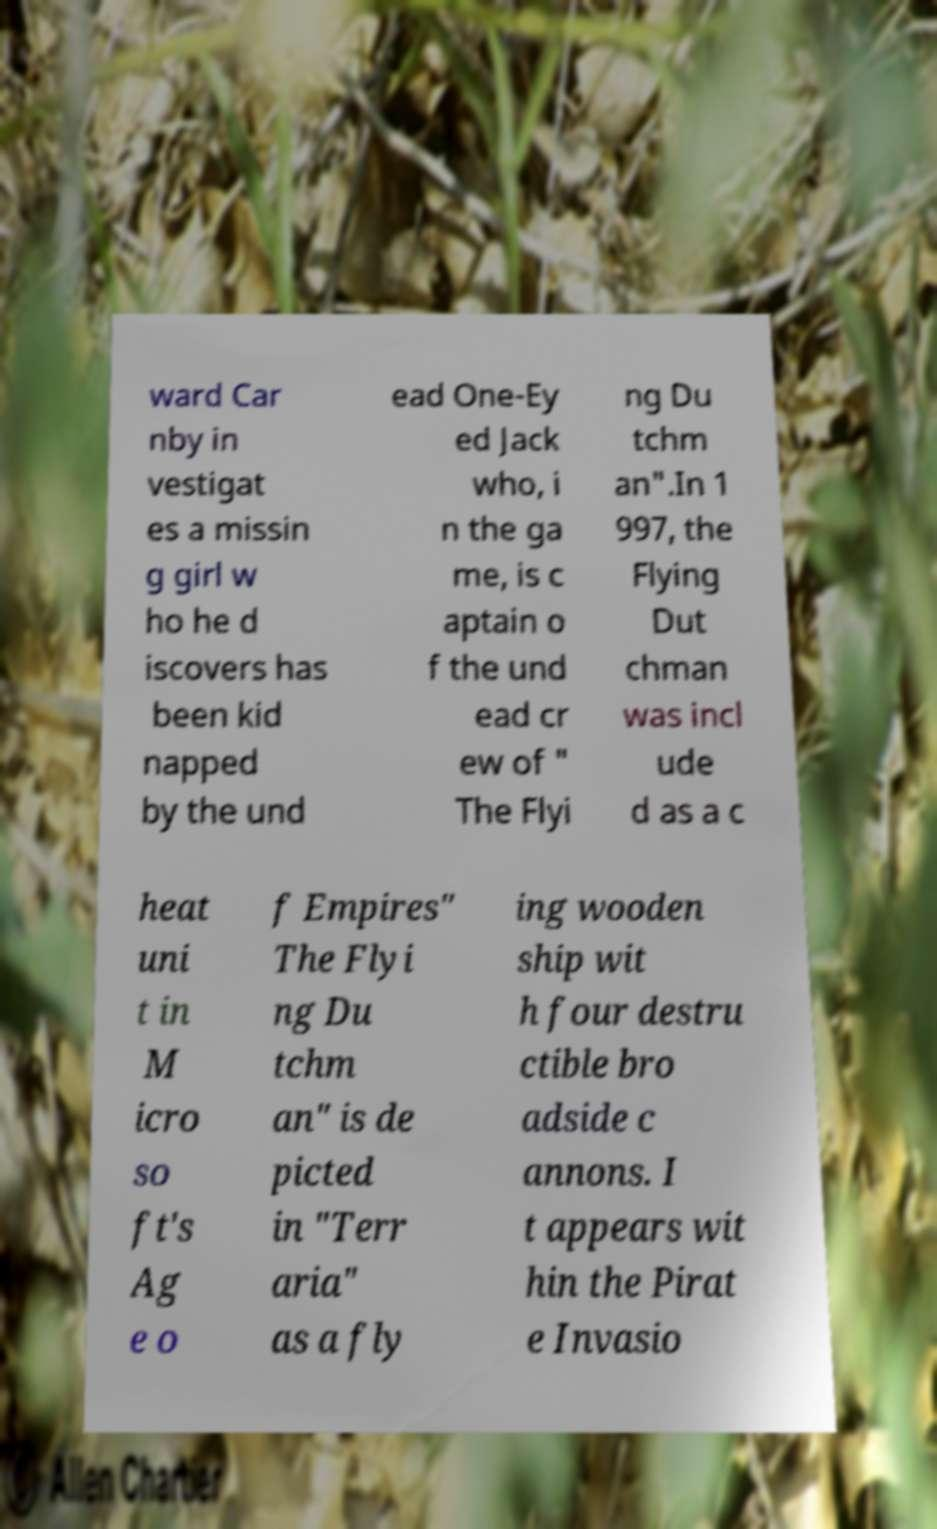I need the written content from this picture converted into text. Can you do that? ward Car nby in vestigat es a missin g girl w ho he d iscovers has been kid napped by the und ead One-Ey ed Jack who, i n the ga me, is c aptain o f the und ead cr ew of " The Flyi ng Du tchm an".In 1 997, the Flying Dut chman was incl ude d as a c heat uni t in M icro so ft's Ag e o f Empires" The Flyi ng Du tchm an" is de picted in "Terr aria" as a fly ing wooden ship wit h four destru ctible bro adside c annons. I t appears wit hin the Pirat e Invasio 